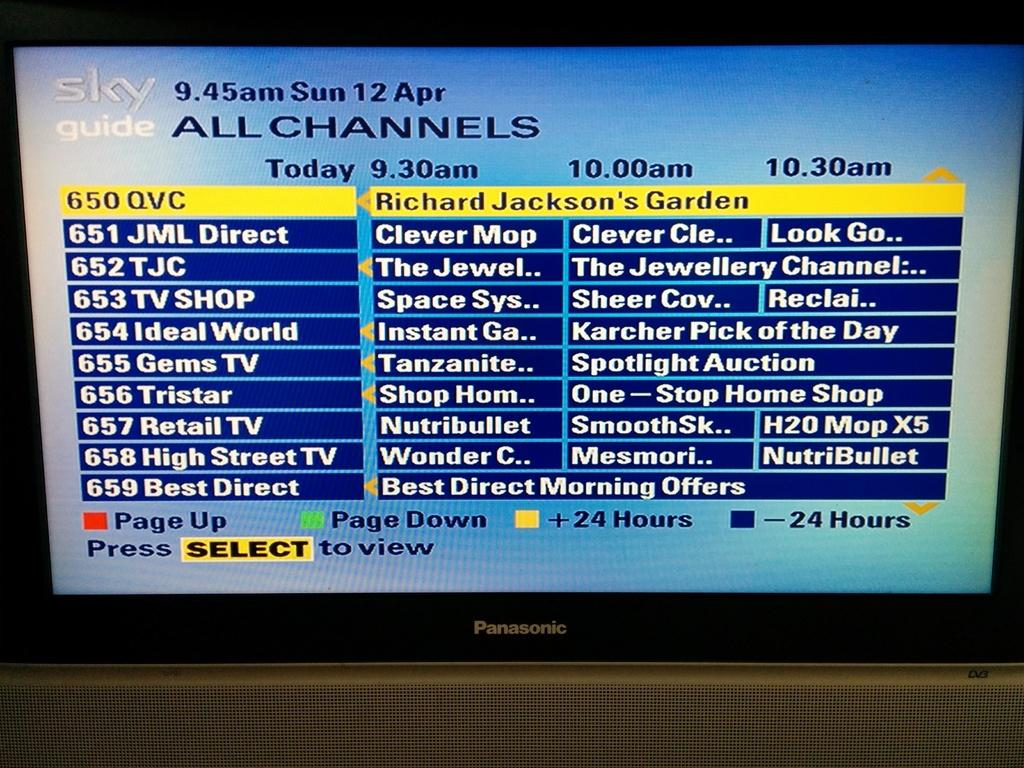<image>
Render a clear and concise summary of the photo. sky guide has channels on the screen of the device 